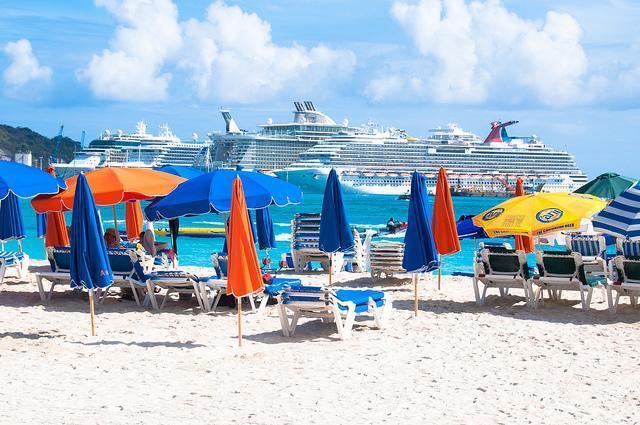How many open umbrellas are there on the beach?
Give a very brief answer. 7. How many boats are there?
Give a very brief answer. 3. How many chairs are there?
Give a very brief answer. 3. How many umbrellas are there?
Give a very brief answer. 6. How many zebras in this group?
Give a very brief answer. 0. 